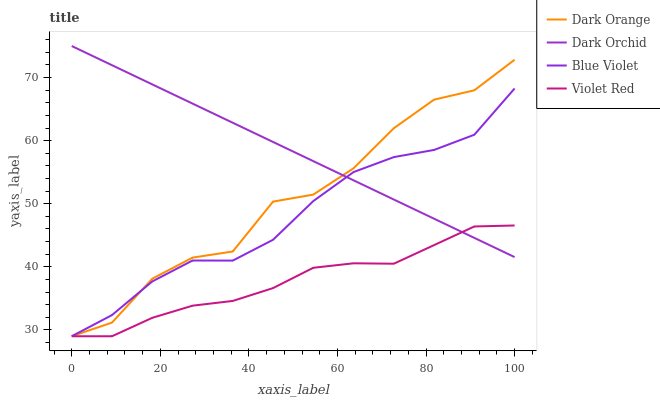Does Blue Violet have the minimum area under the curve?
Answer yes or no. No. Does Blue Violet have the maximum area under the curve?
Answer yes or no. No. Is Violet Red the smoothest?
Answer yes or no. No. Is Violet Red the roughest?
Answer yes or no. No. Does Dark Orchid have the lowest value?
Answer yes or no. No. Does Blue Violet have the highest value?
Answer yes or no. No. 